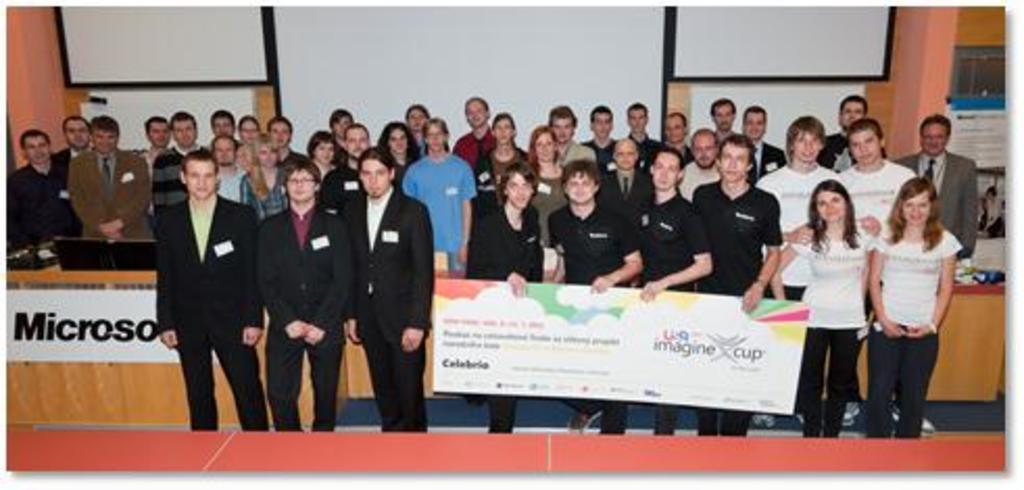What is happening in the image? There are people standing in the image. What are the people at the front holding? Some people at the front are holding a board. What can be seen at the back of the image? There are white boards at the back of the image. Where are the monitors located in the image? The monitors are on the left side of the image. Can you see any ghosts in the image? There are no ghosts present in the image. What type of company is being represented by the people in the image? The image does not provide any information about a company or its representation. 